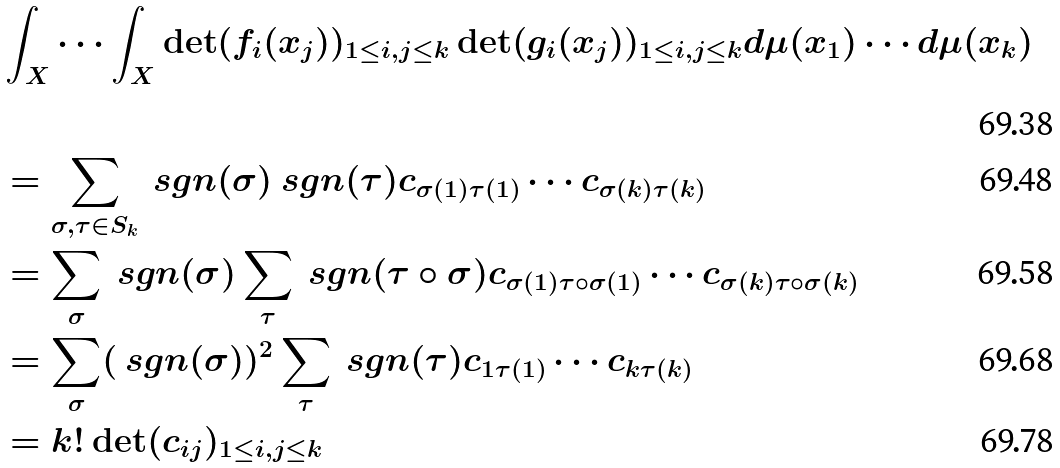Convert formula to latex. <formula><loc_0><loc_0><loc_500><loc_500>& \int _ { X } \cdots \int _ { X } \det ( f _ { i } ( x _ { j } ) ) _ { 1 \leq i , j \leq k } \det ( g _ { i } ( x _ { j } ) ) _ { 1 \leq i , j \leq k } d \mu ( x _ { 1 } ) \cdots d \mu ( x _ { k } ) \\ & = \sum _ { \sigma , \tau \in S _ { k } } \ s g n ( \sigma ) \ s g n ( \tau ) c _ { \sigma ( 1 ) \tau ( 1 ) } \cdots c _ { \sigma ( k ) \tau ( k ) } \\ & = \sum _ { \sigma } \ s g n ( \sigma ) \sum _ { \tau } \ s g n ( \tau \circ \sigma ) c _ { \sigma ( 1 ) \tau \circ \sigma ( 1 ) } \cdots c _ { \sigma ( k ) \tau \circ \sigma ( k ) } \\ & = \sum _ { \sigma } ( \ s g n ( \sigma ) ) ^ { 2 } \sum _ { \tau } \ s g n ( \tau ) c _ { 1 \tau ( 1 ) } \cdots c _ { k \tau ( k ) } \\ & = k ! \det ( c _ { i j } ) _ { 1 \leq i , j \leq k }</formula> 